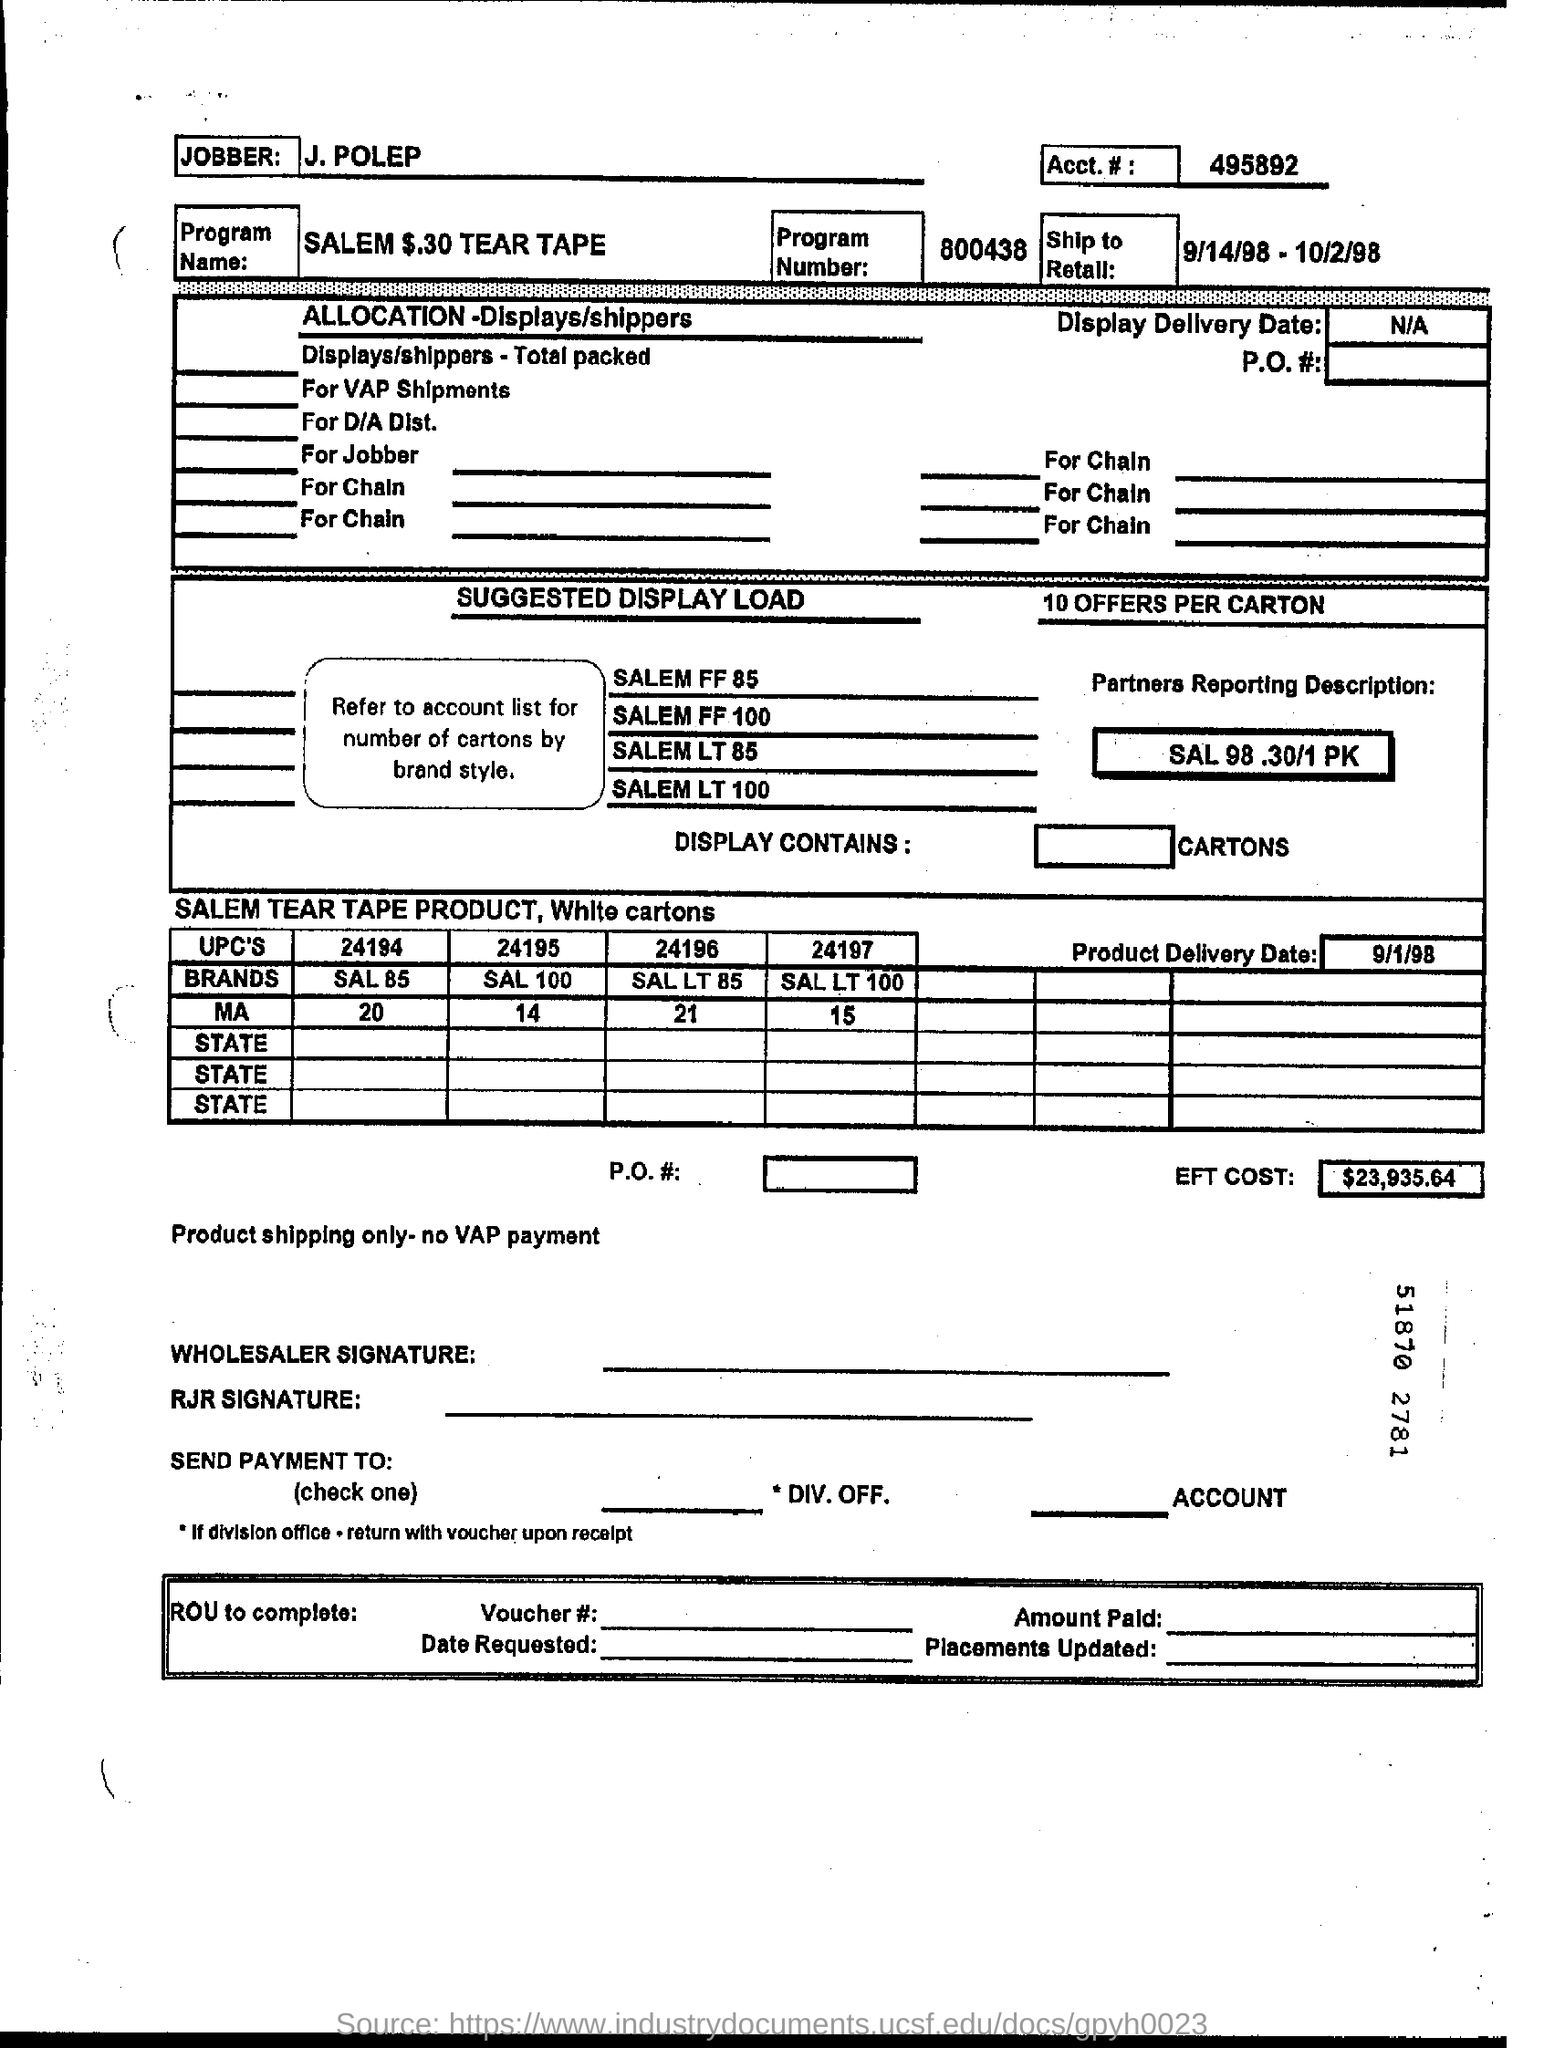Indicate a few pertinent items in this graphic. The total cost of EFT is $23,935.64. The Program Name is SALEM $.30 TEAR TAPE. The individual named J. Polep is the jobber. What is the account number for account number 495892? What is the program number?" is a question asked to clarify the specific program or initiative that someone is referring to. The program number in question is 800438, which is a unique identifier for the program. 